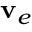Convert formula to latex. <formula><loc_0><loc_0><loc_500><loc_500>v _ { e }</formula> 